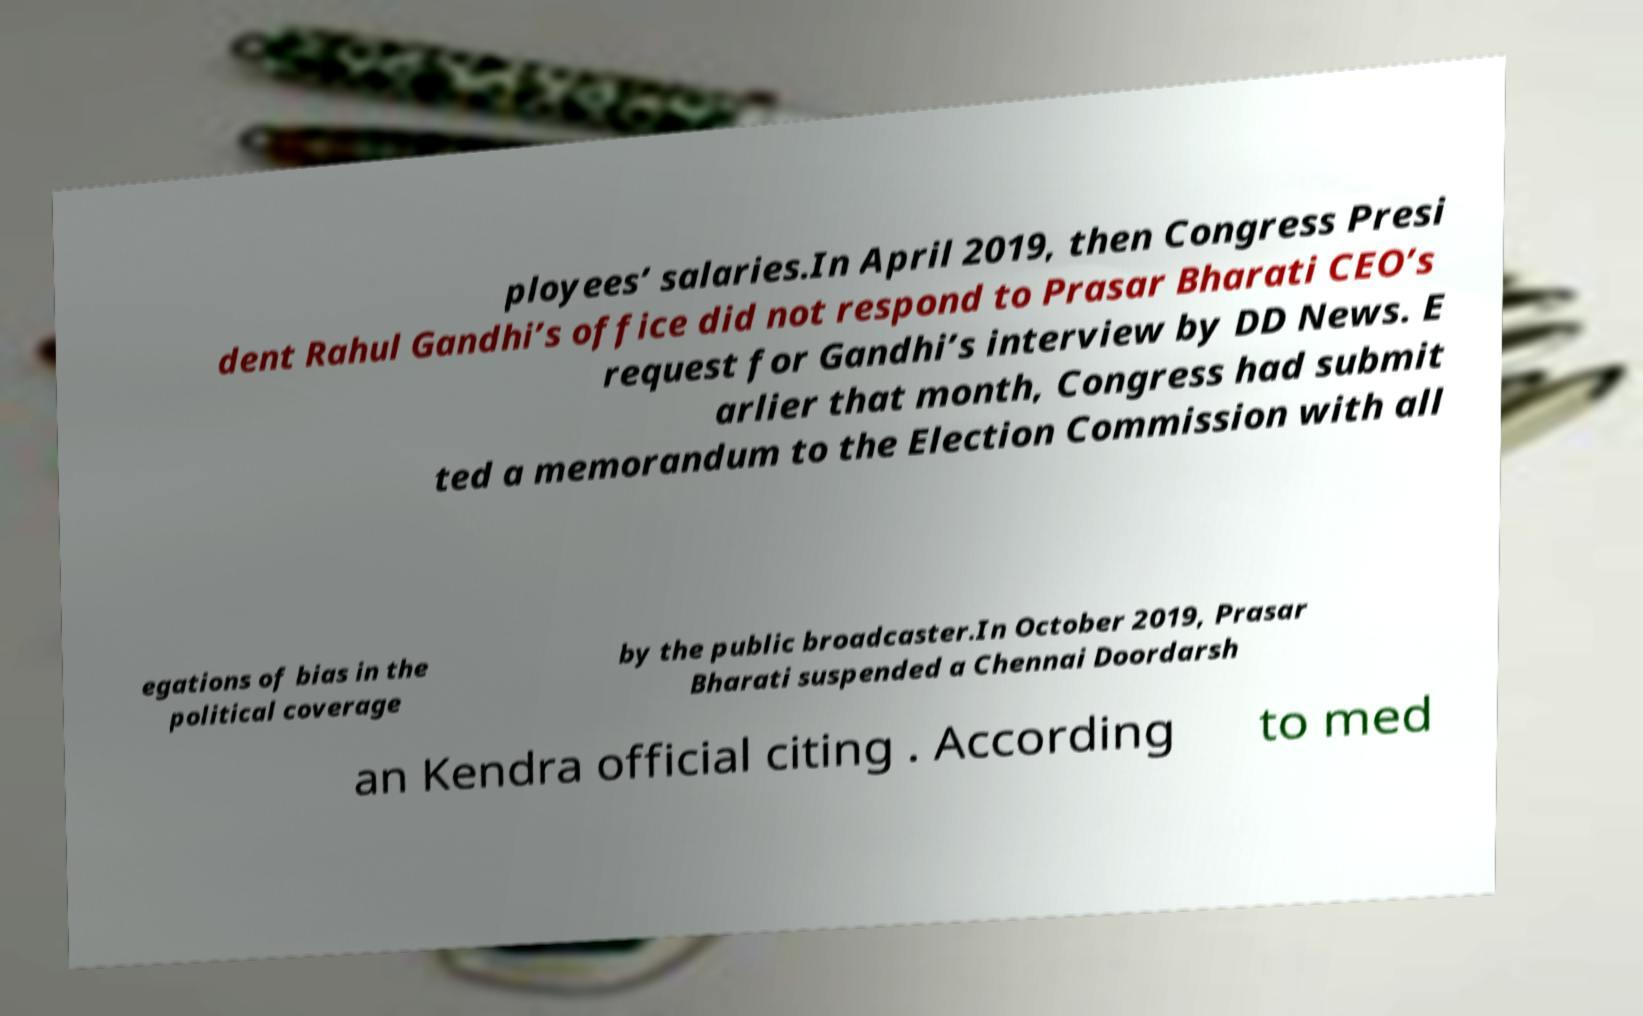For documentation purposes, I need the text within this image transcribed. Could you provide that? ployees’ salaries.In April 2019, then Congress Presi dent Rahul Gandhi’s office did not respond to Prasar Bharati CEO’s request for Gandhi’s interview by DD News. E arlier that month, Congress had submit ted a memorandum to the Election Commission with all egations of bias in the political coverage by the public broadcaster.In October 2019, Prasar Bharati suspended a Chennai Doordarsh an Kendra official citing . According to med 